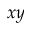Convert formula to latex. <formula><loc_0><loc_0><loc_500><loc_500>x y</formula> 